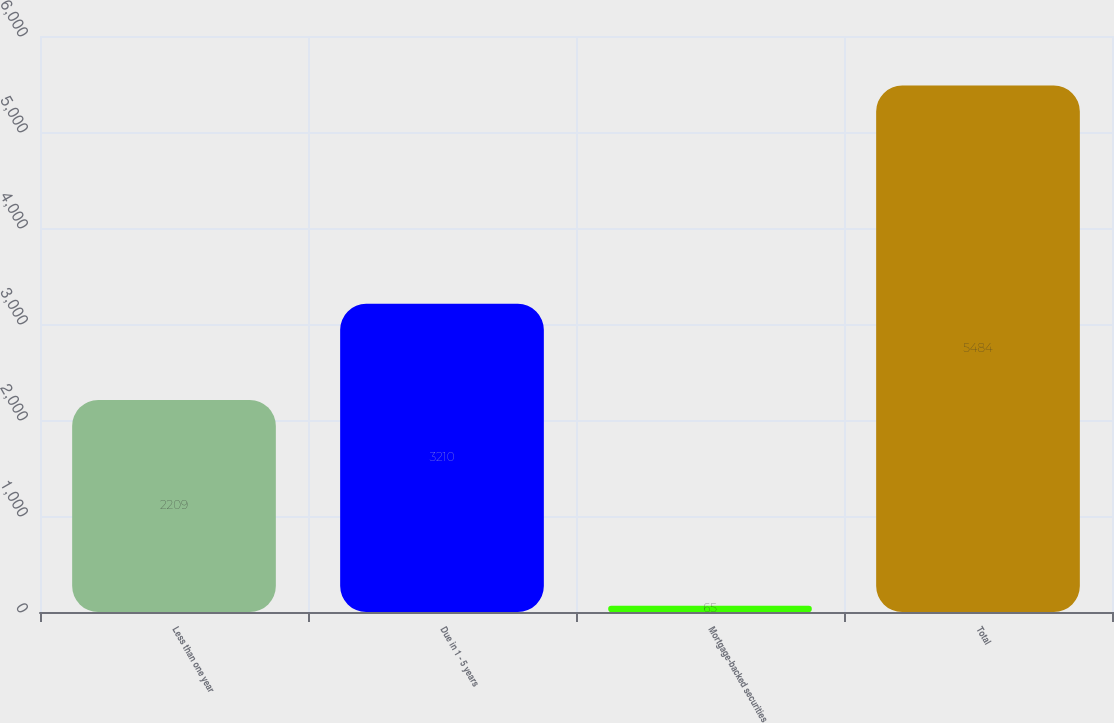<chart> <loc_0><loc_0><loc_500><loc_500><bar_chart><fcel>Less than one year<fcel>Due in 1 - 5 years<fcel>Mortgage-backed securities<fcel>Total<nl><fcel>2209<fcel>3210<fcel>65<fcel>5484<nl></chart> 